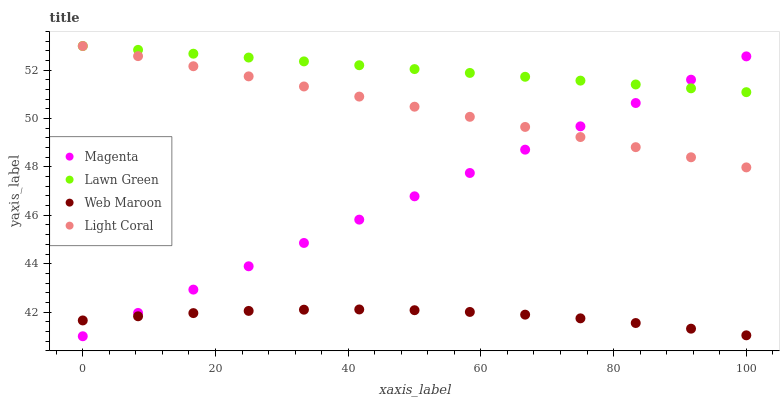Does Web Maroon have the minimum area under the curve?
Answer yes or no. Yes. Does Lawn Green have the maximum area under the curve?
Answer yes or no. Yes. Does Magenta have the minimum area under the curve?
Answer yes or no. No. Does Magenta have the maximum area under the curve?
Answer yes or no. No. Is Magenta the smoothest?
Answer yes or no. Yes. Is Web Maroon the roughest?
Answer yes or no. Yes. Is Lawn Green the smoothest?
Answer yes or no. No. Is Lawn Green the roughest?
Answer yes or no. No. Does Magenta have the lowest value?
Answer yes or no. Yes. Does Lawn Green have the lowest value?
Answer yes or no. No. Does Lawn Green have the highest value?
Answer yes or no. Yes. Does Magenta have the highest value?
Answer yes or no. No. Is Web Maroon less than Lawn Green?
Answer yes or no. Yes. Is Light Coral greater than Web Maroon?
Answer yes or no. Yes. Does Magenta intersect Web Maroon?
Answer yes or no. Yes. Is Magenta less than Web Maroon?
Answer yes or no. No. Is Magenta greater than Web Maroon?
Answer yes or no. No. Does Web Maroon intersect Lawn Green?
Answer yes or no. No. 